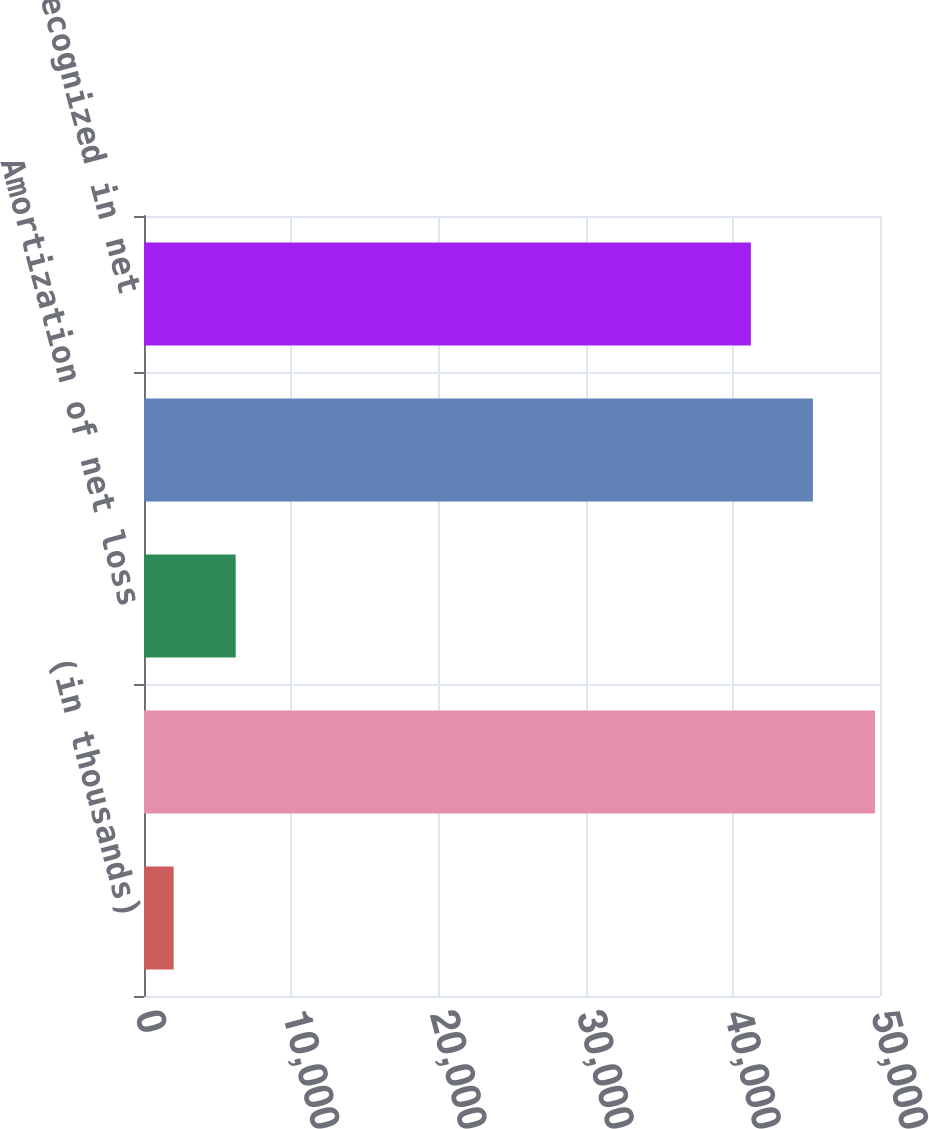Convert chart. <chart><loc_0><loc_0><loc_500><loc_500><bar_chart><fcel>(in thousands)<fcel>Pretax (income)/loss<fcel>Amortization of net loss<fcel>Total recognized in other<fcel>Total recognized in net<nl><fcel>2014<fcel>49658<fcel>6228.5<fcel>45443.5<fcel>41229<nl></chart> 